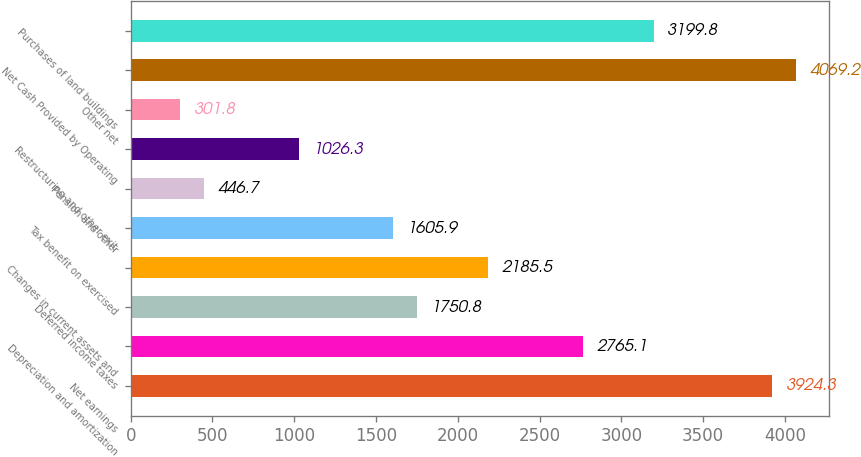Convert chart. <chart><loc_0><loc_0><loc_500><loc_500><bar_chart><fcel>Net earnings<fcel>Depreciation and amortization<fcel>Deferred income taxes<fcel>Changes in current assets and<fcel>Tax benefit on exercised<fcel>Pension and other<fcel>Restructuring and other exit<fcel>Other net<fcel>Net Cash Provided by Operating<fcel>Purchases of land buildings<nl><fcel>3924.3<fcel>2765.1<fcel>1750.8<fcel>2185.5<fcel>1605.9<fcel>446.7<fcel>1026.3<fcel>301.8<fcel>4069.2<fcel>3199.8<nl></chart> 